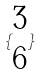Convert formula to latex. <formula><loc_0><loc_0><loc_500><loc_500>\{ \begin{matrix} 3 \\ 6 \end{matrix} \}</formula> 